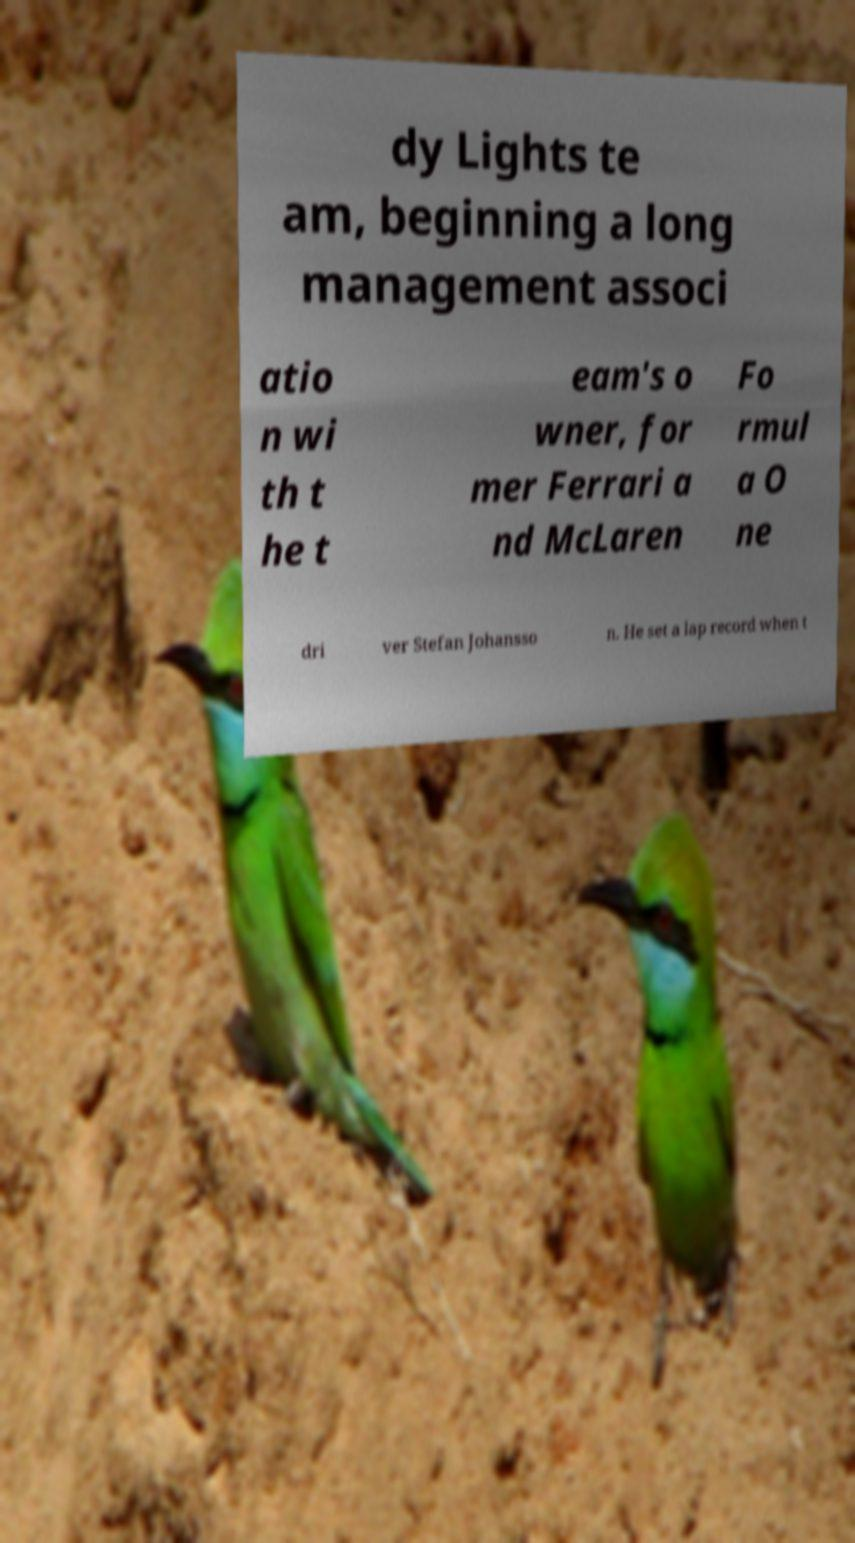Could you extract and type out the text from this image? dy Lights te am, beginning a long management associ atio n wi th t he t eam's o wner, for mer Ferrari a nd McLaren Fo rmul a O ne dri ver Stefan Johansso n. He set a lap record when t 